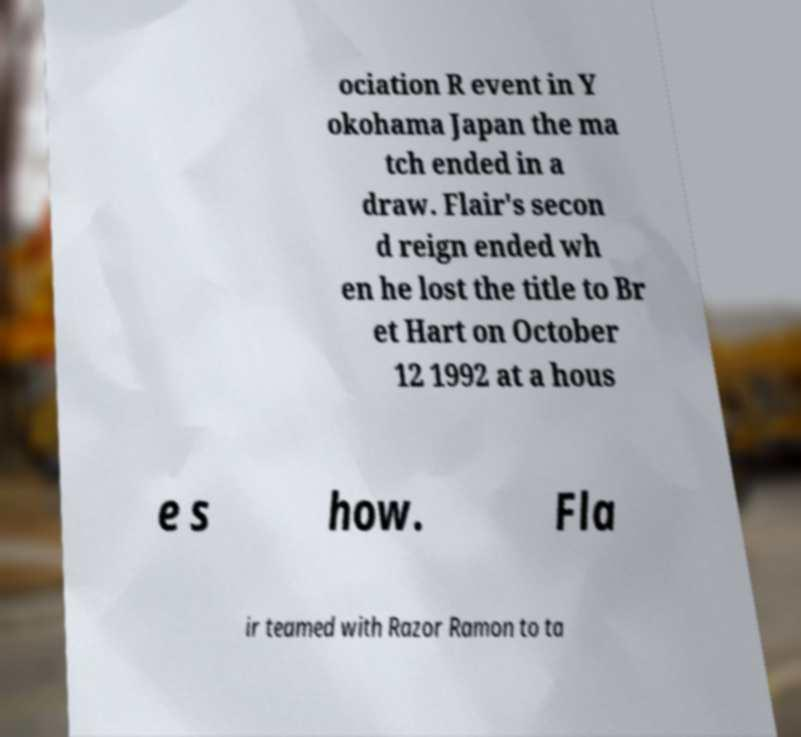What messages or text are displayed in this image? I need them in a readable, typed format. ociation R event in Y okohama Japan the ma tch ended in a draw. Flair's secon d reign ended wh en he lost the title to Br et Hart on October 12 1992 at a hous e s how. Fla ir teamed with Razor Ramon to ta 